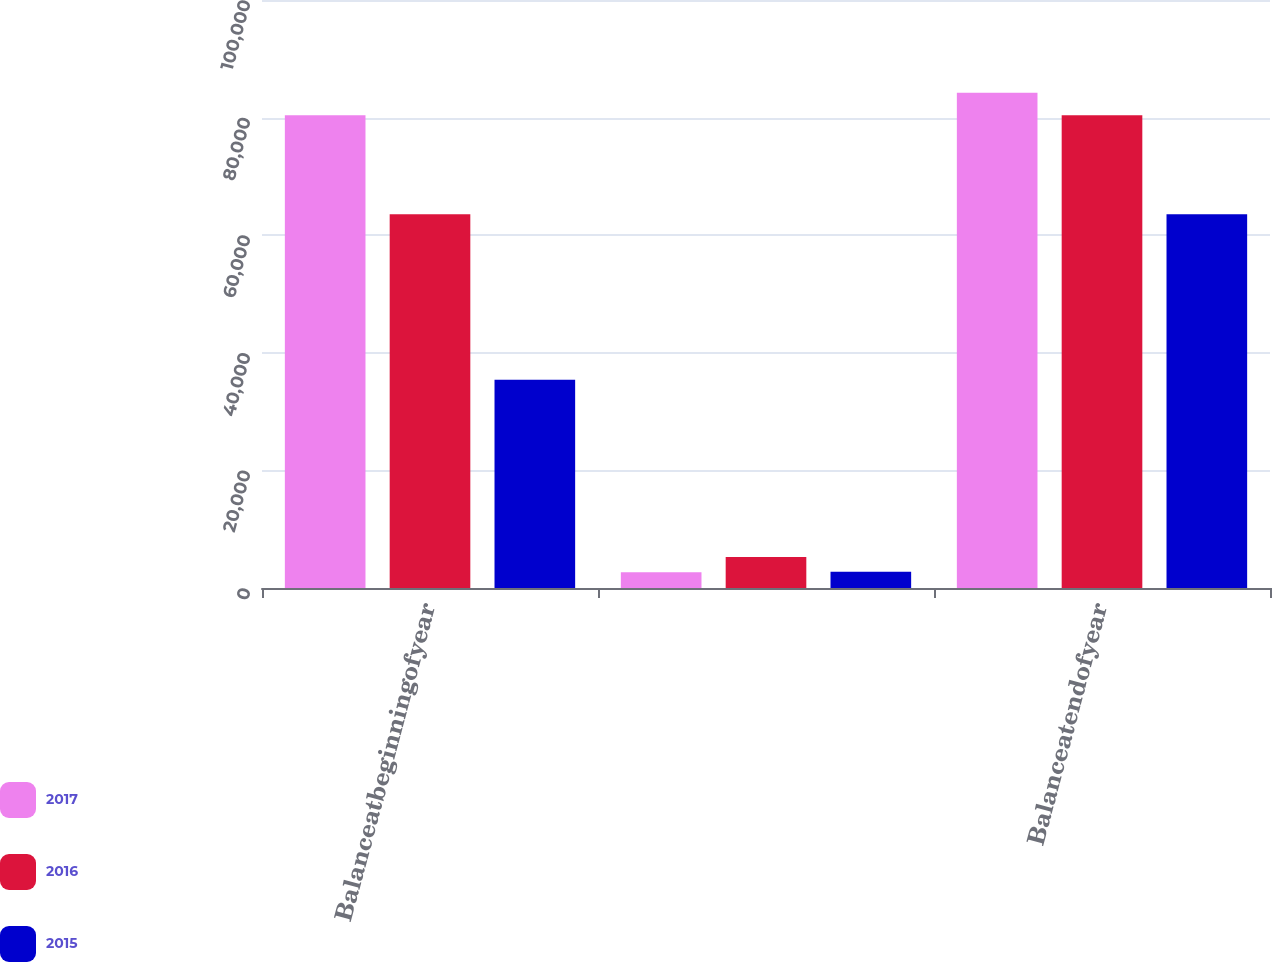Convert chart. <chart><loc_0><loc_0><loc_500><loc_500><stacked_bar_chart><ecel><fcel>Balanceatbeginningofyear<fcel>Unnamed: 2<fcel>Balanceatendofyear<nl><fcel>2017<fcel>80388<fcel>2690<fcel>84244<nl><fcel>2016<fcel>63549<fcel>5278<fcel>80388<nl><fcel>2015<fcel>35416<fcel>2777<fcel>63549<nl></chart> 